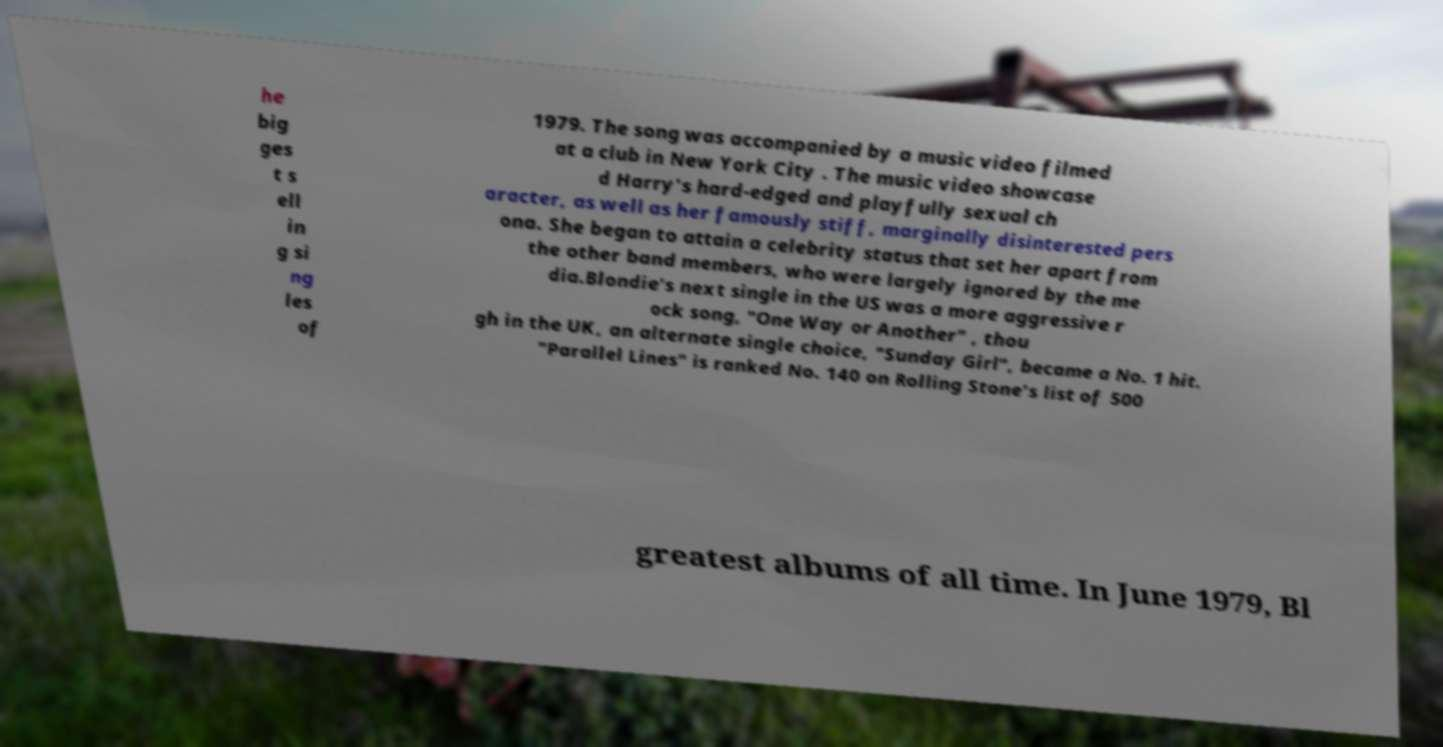Please identify and transcribe the text found in this image. he big ges t s ell in g si ng les of 1979. The song was accompanied by a music video filmed at a club in New York City . The music video showcase d Harry's hard-edged and playfully sexual ch aracter, as well as her famously stiff, marginally disinterested pers ona. She began to attain a celebrity status that set her apart from the other band members, who were largely ignored by the me dia.Blondie's next single in the US was a more aggressive r ock song, "One Way or Another" , thou gh in the UK, an alternate single choice, "Sunday Girl", became a No. 1 hit. "Parallel Lines" is ranked No. 140 on Rolling Stone's list of 500 greatest albums of all time. In June 1979, Bl 